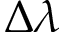<formula> <loc_0><loc_0><loc_500><loc_500>\Delta \lambda</formula> 